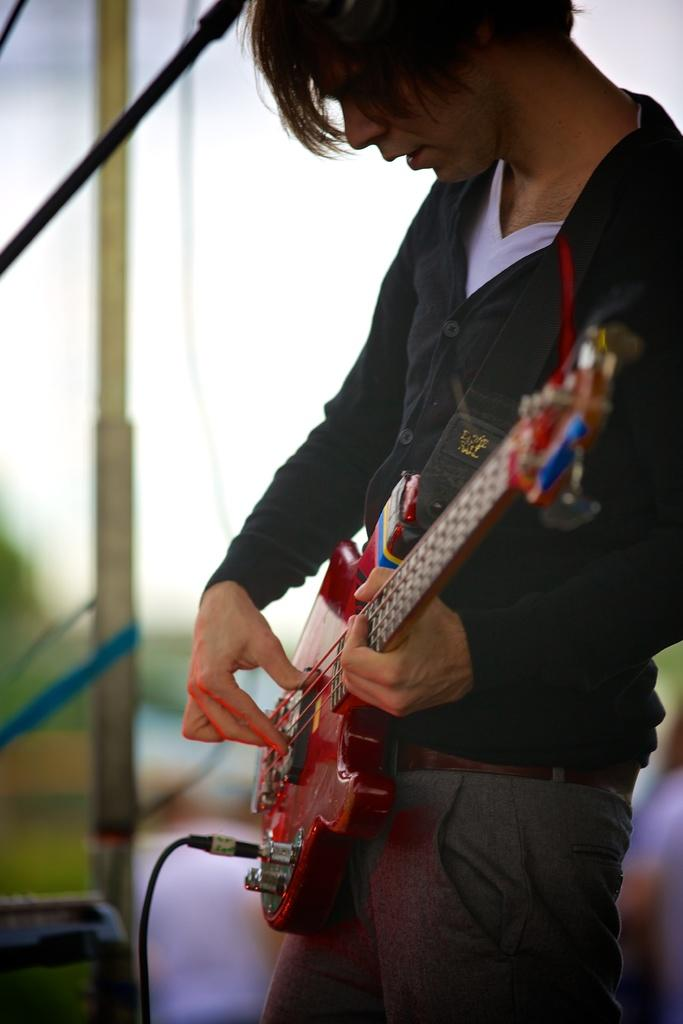What is the man in the image doing? The man is playing a guitar in the image. What is the man wearing in the image? The man is wearing a black jacket in the image. What objects can be seen in the image besides the man and his guitar? There is a rod, a pole, and a wire in the image. What type of bread is being used to support the guitar in the image? There is no bread present in the image, and the guitar is not being supported by any bread. 